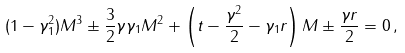<formula> <loc_0><loc_0><loc_500><loc_500>( 1 - \gamma _ { 1 } ^ { 2 } ) M ^ { 3 } \pm \frac { 3 } { 2 } \gamma \gamma _ { 1 } M ^ { 2 } + \left ( t - \frac { \gamma ^ { 2 } } { 2 } - \gamma _ { 1 } r \right ) M \pm \frac { \gamma r } { 2 } = 0 \, ,</formula> 